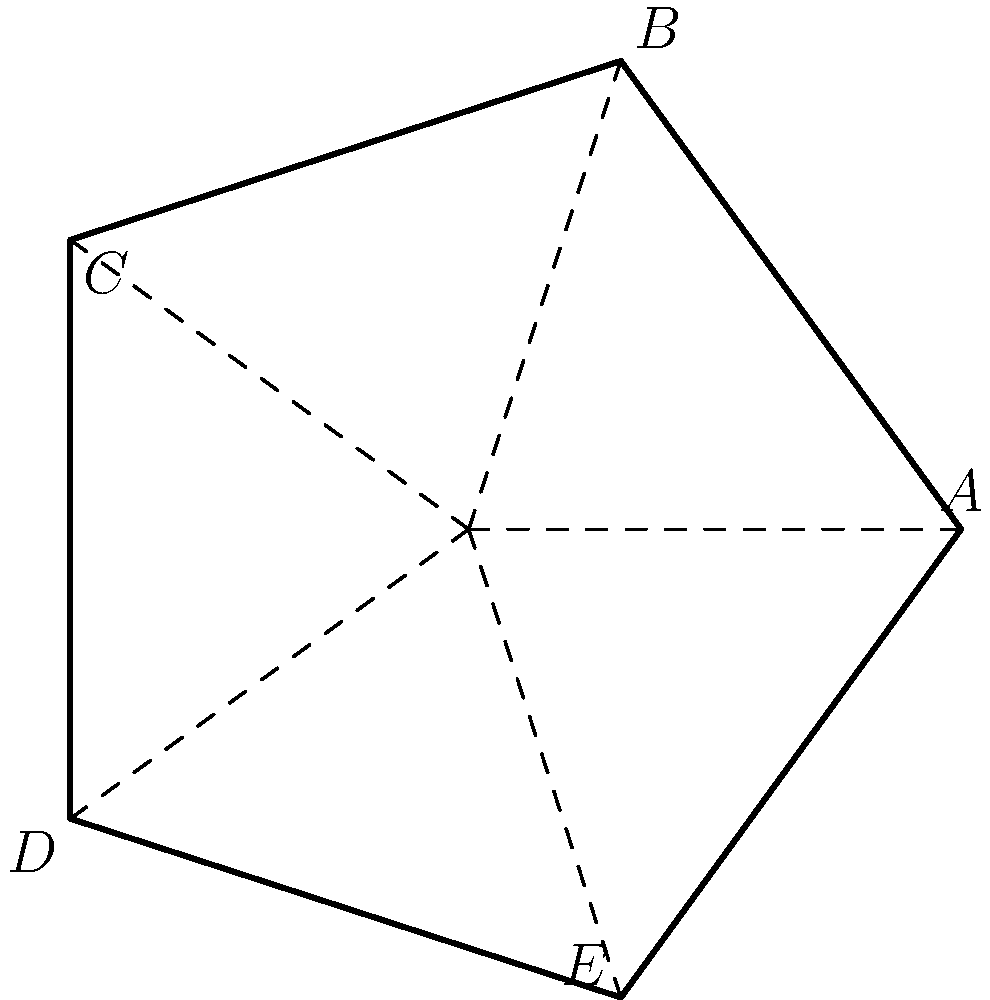In the context of interactive storytelling, consider a digital media project exploring geometric symmetries. Given the regular pentagon ABCDE shown above, how many elements are in its symmetry group? Describe how this concept could be incorporated into an interactive audio experience. To determine the number of elements in the symmetry group of a regular pentagon:

1. Rotational symmetries:
   - The pentagon has 5 rotational symmetries (including the identity rotation)
   - Rotations by 0°, 72°, 144°, 216°, and 288°

2. Reflection symmetries:
   - The pentagon has 5 lines of reflection symmetry
   - One through each vertex and the midpoint of the opposite side

3. Total number of symmetries:
   - Sum of rotational and reflection symmetries
   - 5 (rotations) + 5 (reflections) = 10 elements

Incorporating this into an interactive audio experience:

1. Create a soundscape where each symmetry operation corresponds to a unique sound or musical element.
2. Allow users to "rotate" or "reflect" the pentagon using voice commands or touch interactions.
3. As users perform these operations, play the corresponding sounds, creating a melody or rhythm based on the sequence of symmetry operations.
4. Use spatial audio techniques to represent the geometric transformations sonically, enhancing the immersive experience.
5. Develop a puzzle or game where users must identify symmetries by listening to audio cues, combining mathematical concepts with auditory perception.

This approach would create a unique, interactive storytelling experience that blends mathematics, geometry, and audio in an engaging and educational manner.
Answer: 10 elements; audio mapping of symmetry operations 